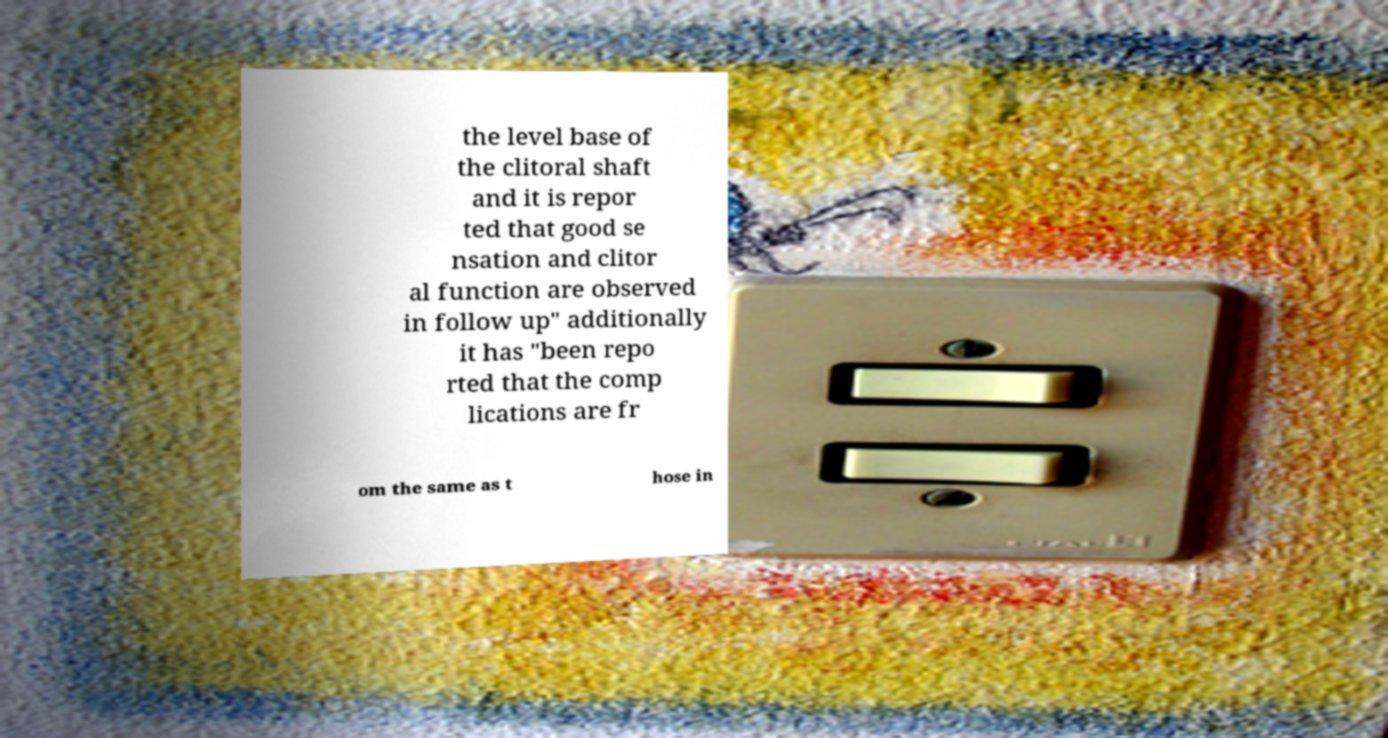Can you accurately transcribe the text from the provided image for me? the level base of the clitoral shaft and it is repor ted that good se nsation and clitor al function are observed in follow up" additionally it has "been repo rted that the comp lications are fr om the same as t hose in 